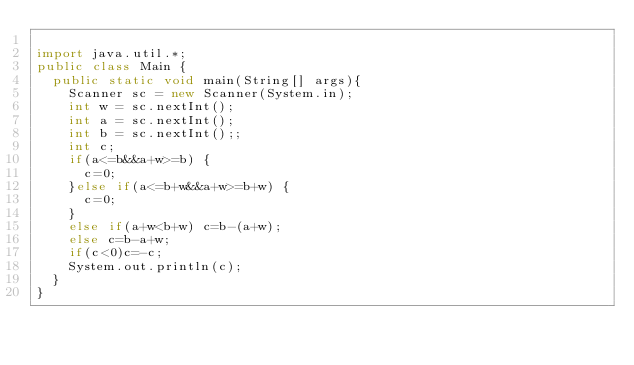Convert code to text. <code><loc_0><loc_0><loc_500><loc_500><_Java_>
import java.util.*;
public class Main {
	public static void main(String[] args){
		Scanner sc = new Scanner(System.in);
		int w = sc.nextInt();
		int a = sc.nextInt();
		int b = sc.nextInt();;
		int c;
		if(a<=b&&a+w>=b) {
			c=0;
		}else if(a<=b+w&&a+w>=b+w) {
			c=0;
		}
		else if(a+w<b+w) c=b-(a+w);
		else c=b-a+w;
		if(c<0)c=-c;
		System.out.println(c);
	}
}</code> 